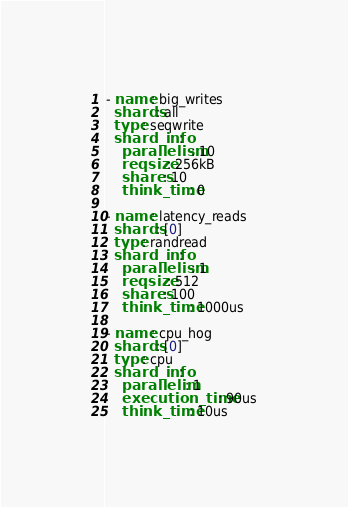<code> <loc_0><loc_0><loc_500><loc_500><_YAML_>- name: big_writes
  shards: all
  type: seqwrite
  shard_info:
    parallelism: 10
    reqsize: 256kB
    shares: 10
    think_time: 0

- name: latency_reads
  shards: [0]
  type: randread
  shard_info:
    parallelism: 1
    reqsize: 512
    shares: 100
    think_time: 1000us

- name: cpu_hog
  shards: [0]
  type: cpu
  shard_info:
    parallelim: 1
    execution_time: 90us
    think_time: 10us
</code> 